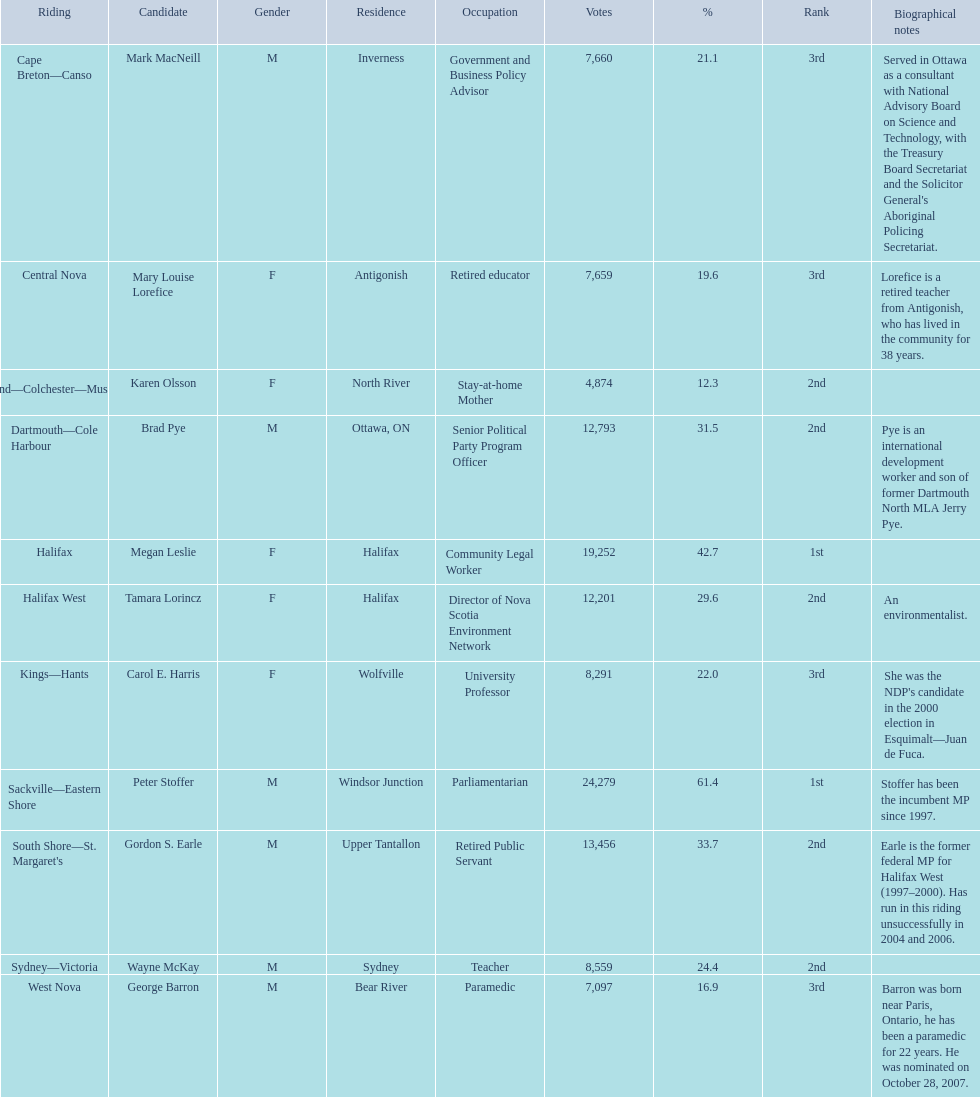Which candidates have the four lowest amount of votes Mark MacNeill, Mary Louise Lorefice, Karen Olsson, George Barron. Out of the following, who has the third most? Mark MacNeill. 